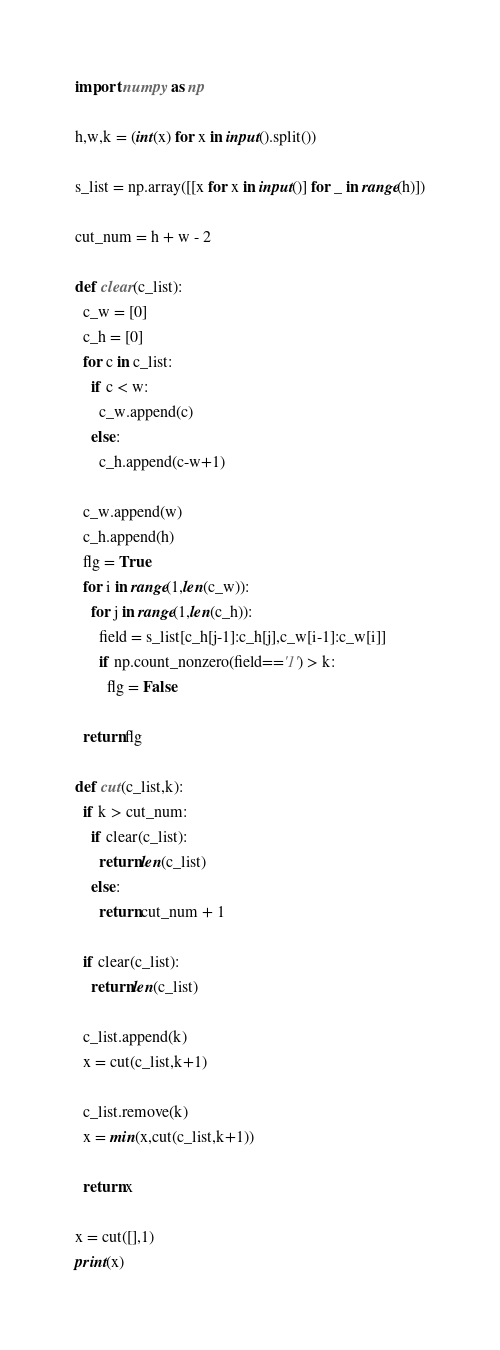Convert code to text. <code><loc_0><loc_0><loc_500><loc_500><_Python_>import numpy as np

h,w,k = (int(x) for x in input().split())

s_list = np.array([[x for x in input()] for _ in range(h)])

cut_num = h + w - 2

def clear(c_list):
  c_w = [0]
  c_h = [0]
  for c in c_list:
    if c < w:
      c_w.append(c)
    else:
      c_h.append(c-w+1)
      
  c_w.append(w)
  c_h.append(h)
  flg = True
  for i in range(1,len(c_w)):
    for j in range(1,len(c_h)):
      field = s_list[c_h[j-1]:c_h[j],c_w[i-1]:c_w[i]]
      if np.count_nonzero(field=='1') > k:
        flg = False
        
  return flg
      
def cut(c_list,k):
  if k > cut_num:
    if clear(c_list):
      return len(c_list)
    else:
      return cut_num + 1
  
  if clear(c_list):
    return len(c_list)
    
  c_list.append(k)
  x = cut(c_list,k+1)

  c_list.remove(k)
  x = min(x,cut(c_list,k+1))
  
  return x

x = cut([],1)
print(x)</code> 